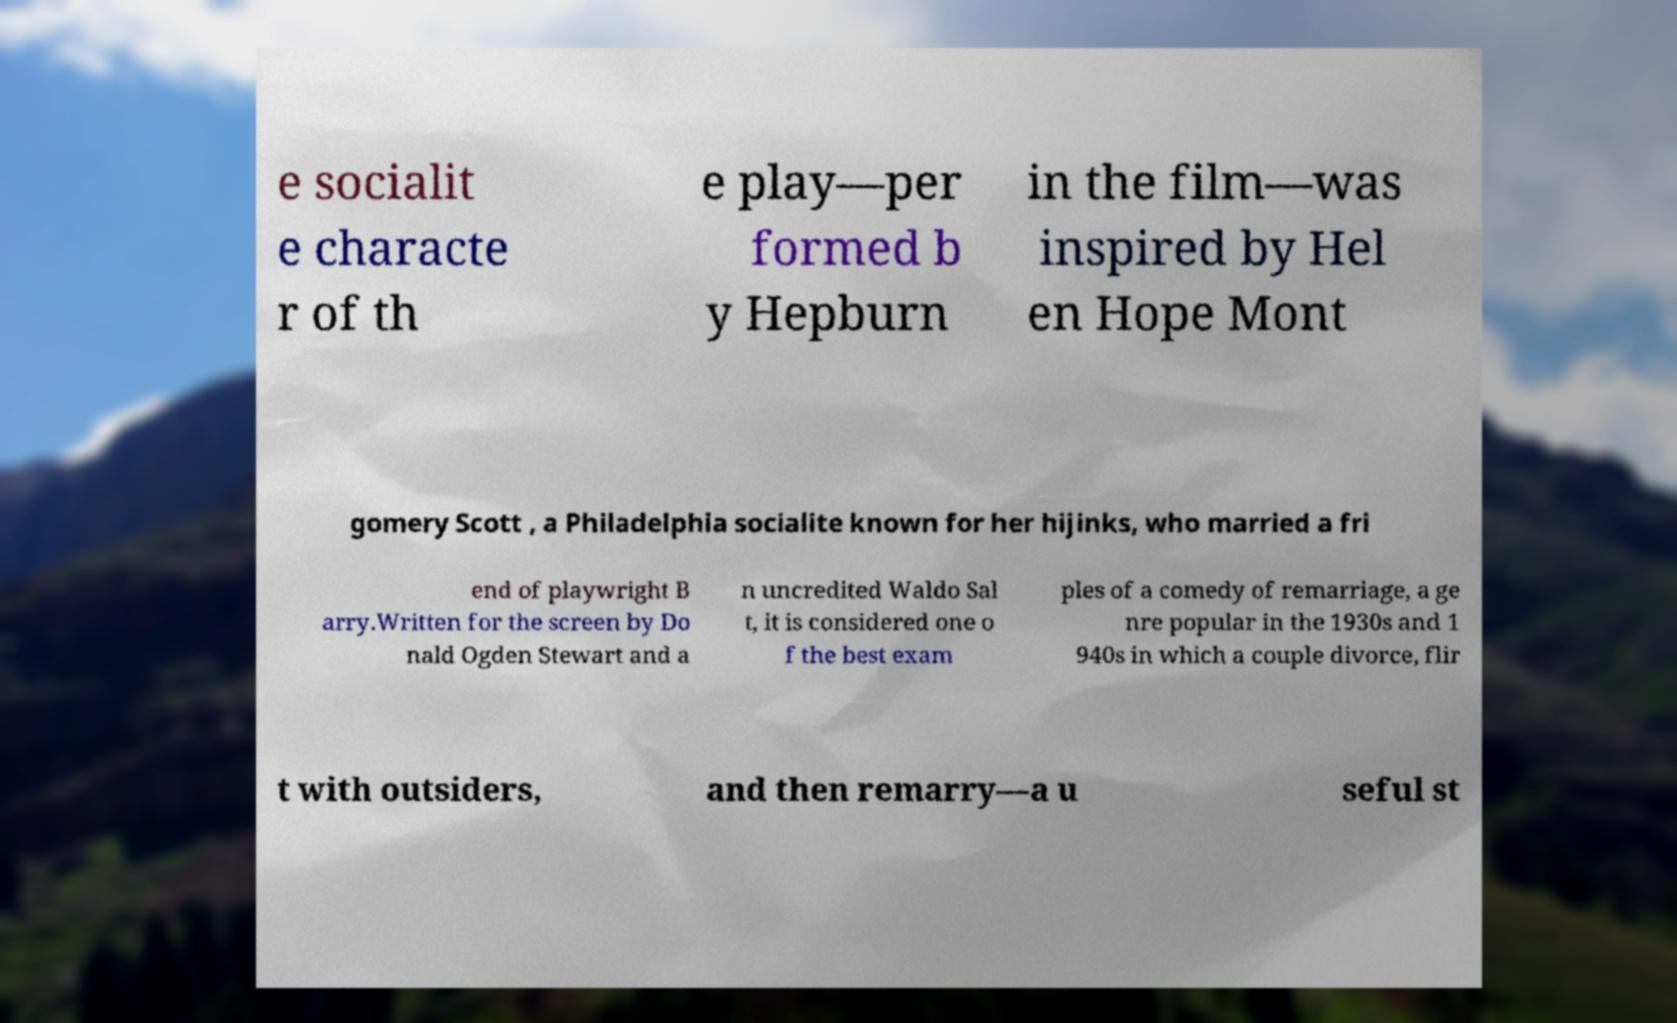What messages or text are displayed in this image? I need them in a readable, typed format. e socialit e characte r of th e play—per formed b y Hepburn in the film—was inspired by Hel en Hope Mont gomery Scott , a Philadelphia socialite known for her hijinks, who married a fri end of playwright B arry.Written for the screen by Do nald Ogden Stewart and a n uncredited Waldo Sal t, it is considered one o f the best exam ples of a comedy of remarriage, a ge nre popular in the 1930s and 1 940s in which a couple divorce, flir t with outsiders, and then remarry—a u seful st 